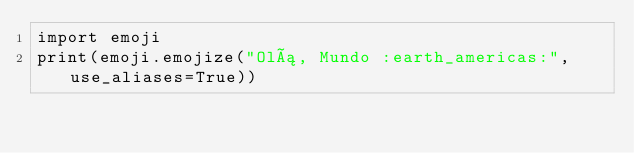Convert code to text. <code><loc_0><loc_0><loc_500><loc_500><_Python_>import emoji
print(emoji.emojize("Olá, Mundo :earth_americas:", use_aliases=True))

</code> 